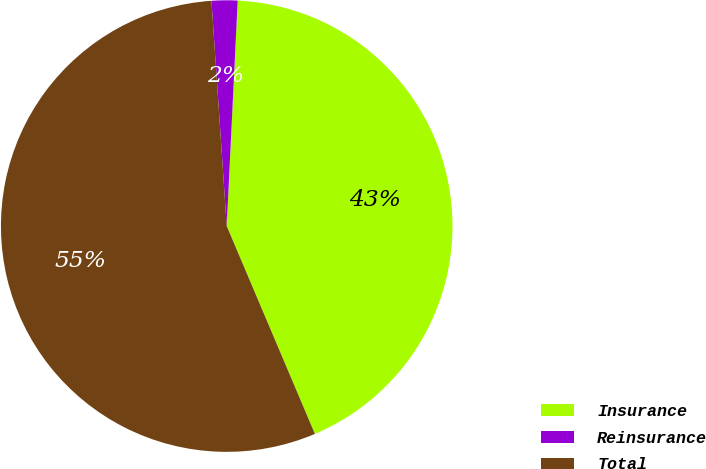Convert chart. <chart><loc_0><loc_0><loc_500><loc_500><pie_chart><fcel>Insurance<fcel>Reinsurance<fcel>Total<nl><fcel>42.84%<fcel>1.85%<fcel>55.31%<nl></chart> 